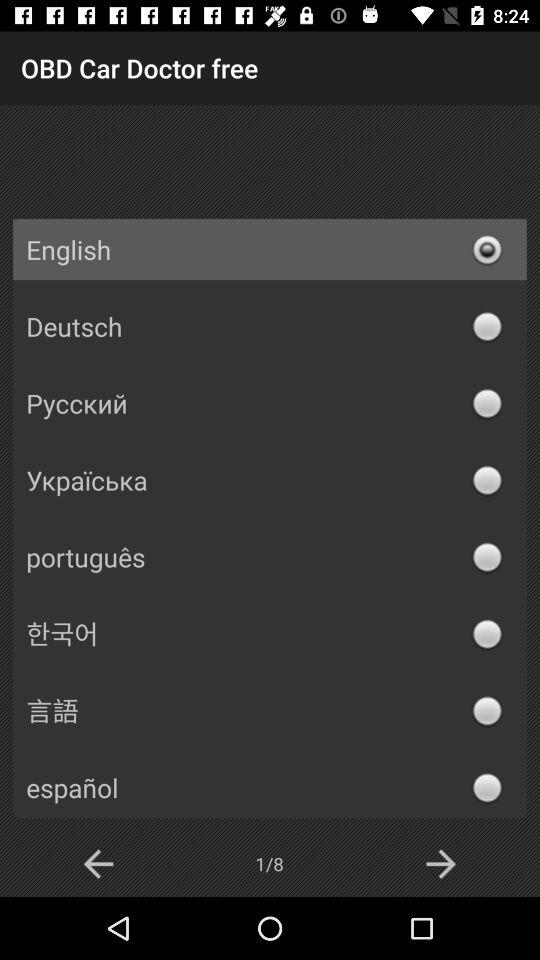Which page am I on? You are on page 1. 